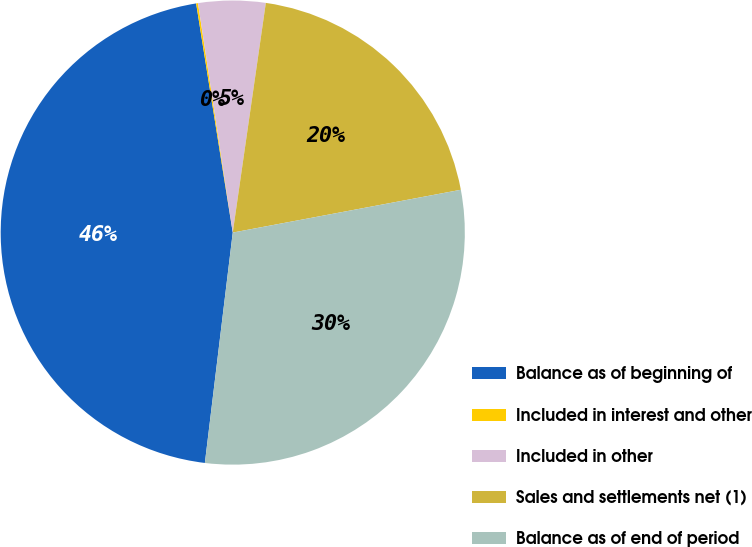<chart> <loc_0><loc_0><loc_500><loc_500><pie_chart><fcel>Balance as of beginning of<fcel>Included in interest and other<fcel>Included in other<fcel>Sales and settlements net (1)<fcel>Balance as of end of period<nl><fcel>45.56%<fcel>0.13%<fcel>4.67%<fcel>19.77%<fcel>29.87%<nl></chart> 